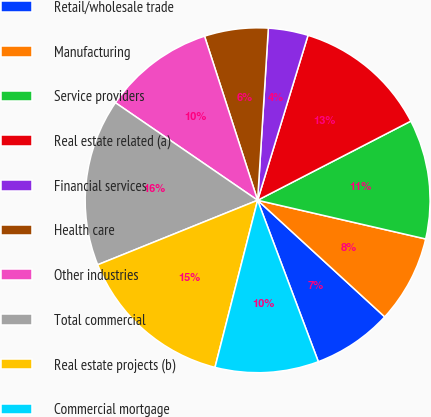Convert chart to OTSL. <chart><loc_0><loc_0><loc_500><loc_500><pie_chart><fcel>Retail/wholesale trade<fcel>Manufacturing<fcel>Service providers<fcel>Real estate related (a)<fcel>Financial services<fcel>Health care<fcel>Other industries<fcel>Total commercial<fcel>Real estate projects (b)<fcel>Commercial mortgage<nl><fcel>7.46%<fcel>8.21%<fcel>11.19%<fcel>12.69%<fcel>3.73%<fcel>5.97%<fcel>10.45%<fcel>15.67%<fcel>14.92%<fcel>9.7%<nl></chart> 